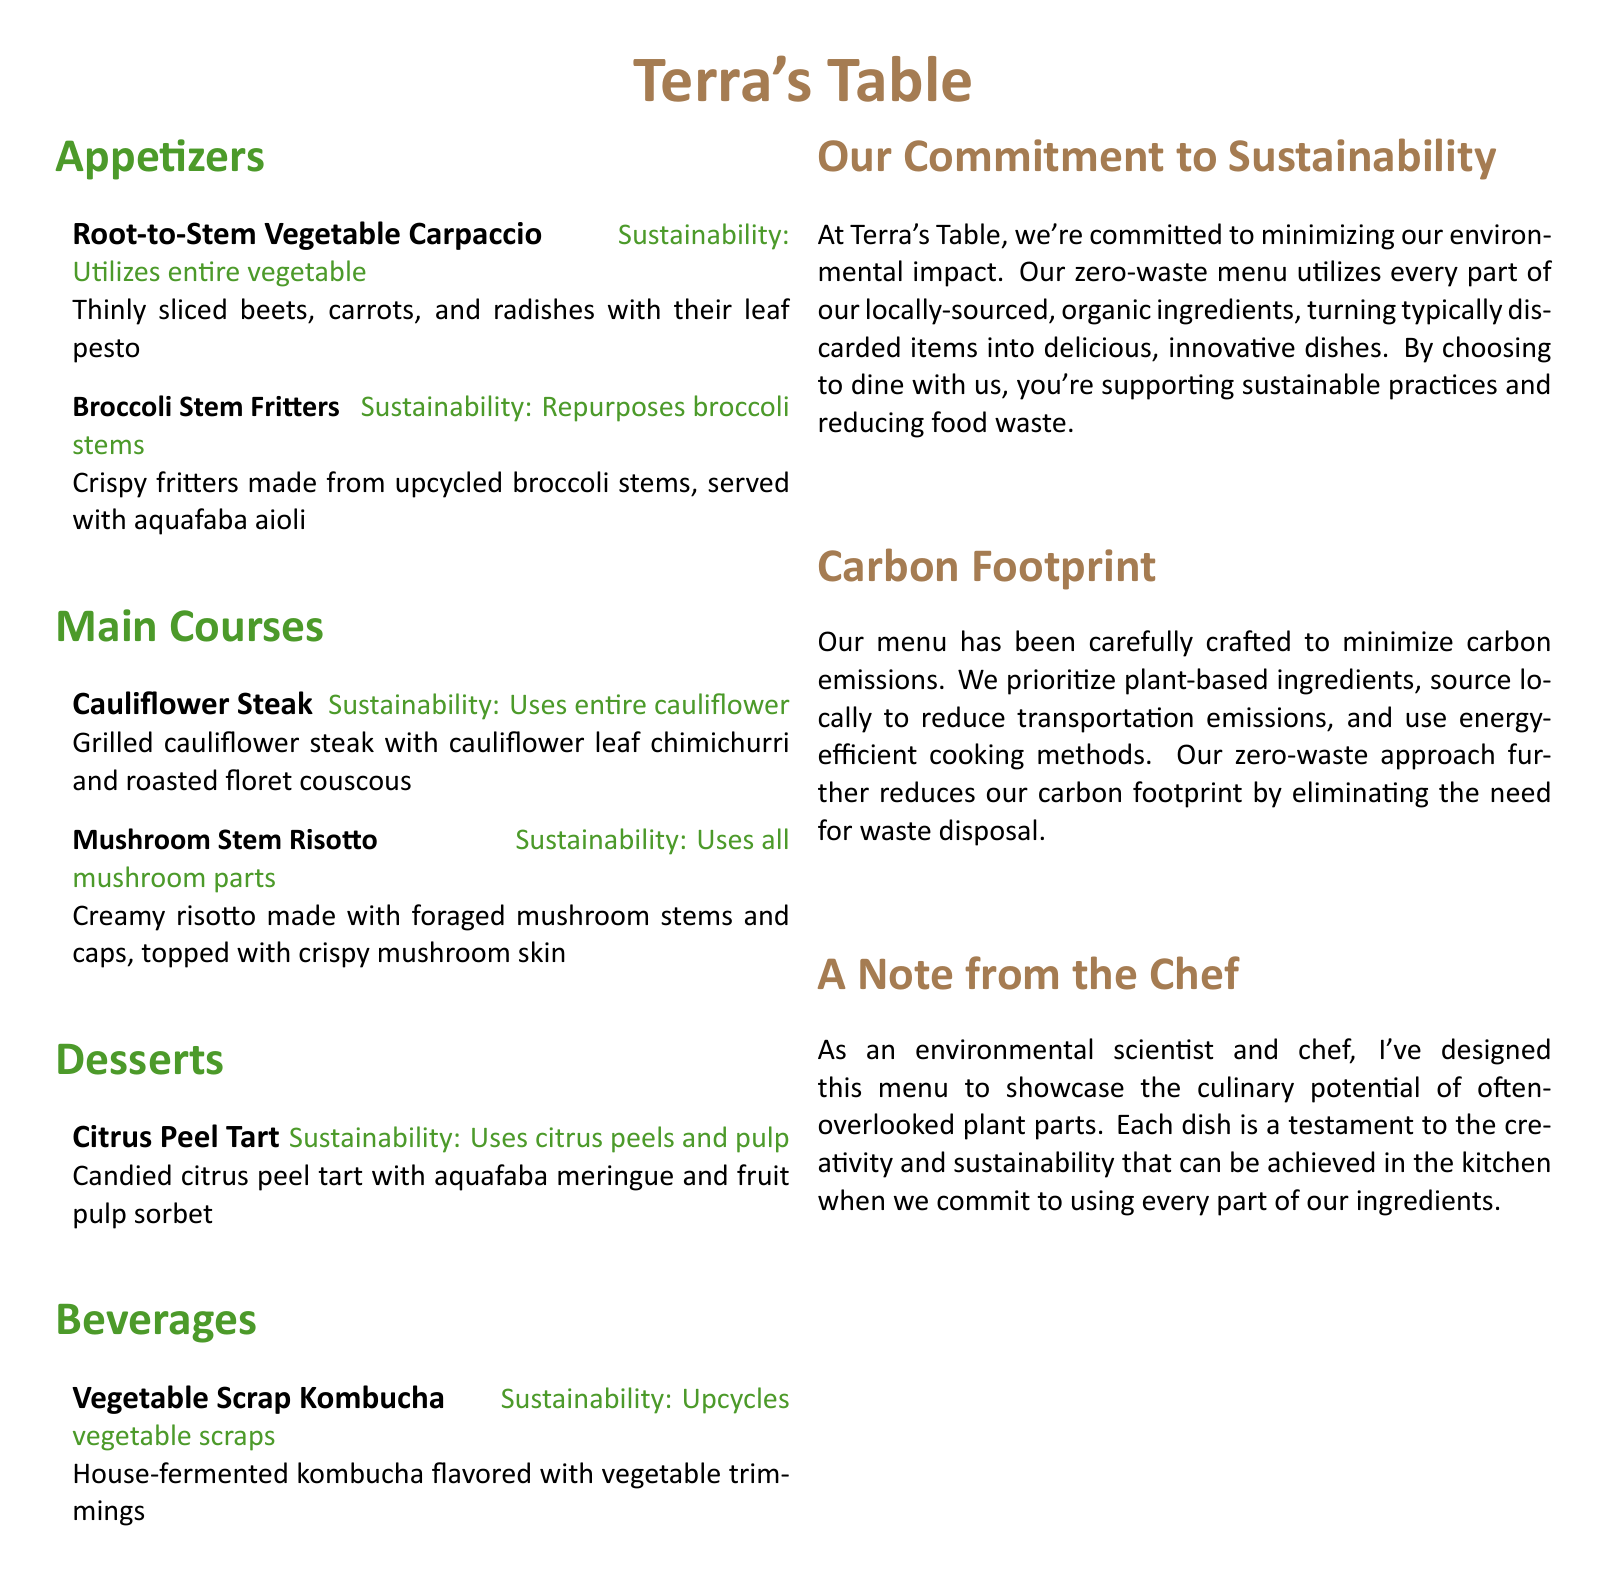What is the name of the restaurant? The restaurant is titled "Terra's Table" in the document.
Answer: Terra's Table What type of menu is featured? The document describes a menu that focuses on sustainability and a zero-waste approach.
Answer: Zero-waste menu Which vegetable is used in the "Broccoli Stem Fritters"? The fritters are specifically made from broccoli stems as mentioned.
Answer: Broccoli stems What dessert utilizes citrus peels and pulp? The document lists a dessert that includes these ingredients, specifically a tart.
Answer: Citrus Peel Tart What beverage is made from vegetable scraps? The kombucha is flavored with vegetable trimmings as stated in the menu.
Answer: Vegetable Scrap Kombucha What is the primary focus of the "Our Commitment to Sustainability" section? This section emphasizes minimizing environmental impact and reducing food waste.
Answer: Minimizing environmental impact How many main courses are listed in the menu? The document counts the main courses, which includes two specific dishes.
Answer: Two Which cooking method is prioritized to reduce carbon emissions? The document mentions a focus on energy-efficient cooking methods to lower emissions.
Answer: Energy-efficient cooking methods What does the chef aim to showcase with the dishes? The chef intends to highlight the culinary potential of often-overlooked plant parts in the menu.
Answer: Culinary potential of often-overlooked plant parts 